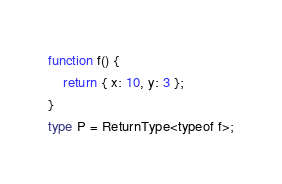Convert code to text. <code><loc_0><loc_0><loc_500><loc_500><_TypeScript_>function f() {
    return { x: 10, y: 3 };
}
type P = ReturnType<typeof f>;</code> 